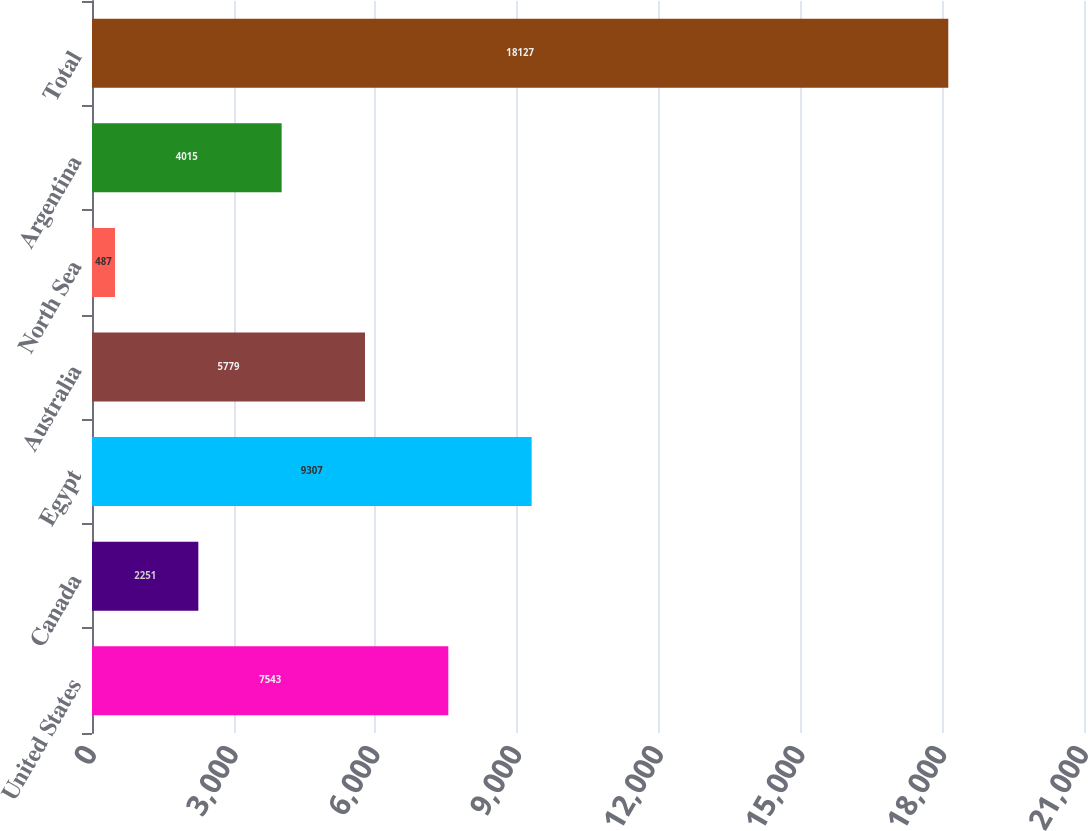<chart> <loc_0><loc_0><loc_500><loc_500><bar_chart><fcel>United States<fcel>Canada<fcel>Egypt<fcel>Australia<fcel>North Sea<fcel>Argentina<fcel>Total<nl><fcel>7543<fcel>2251<fcel>9307<fcel>5779<fcel>487<fcel>4015<fcel>18127<nl></chart> 